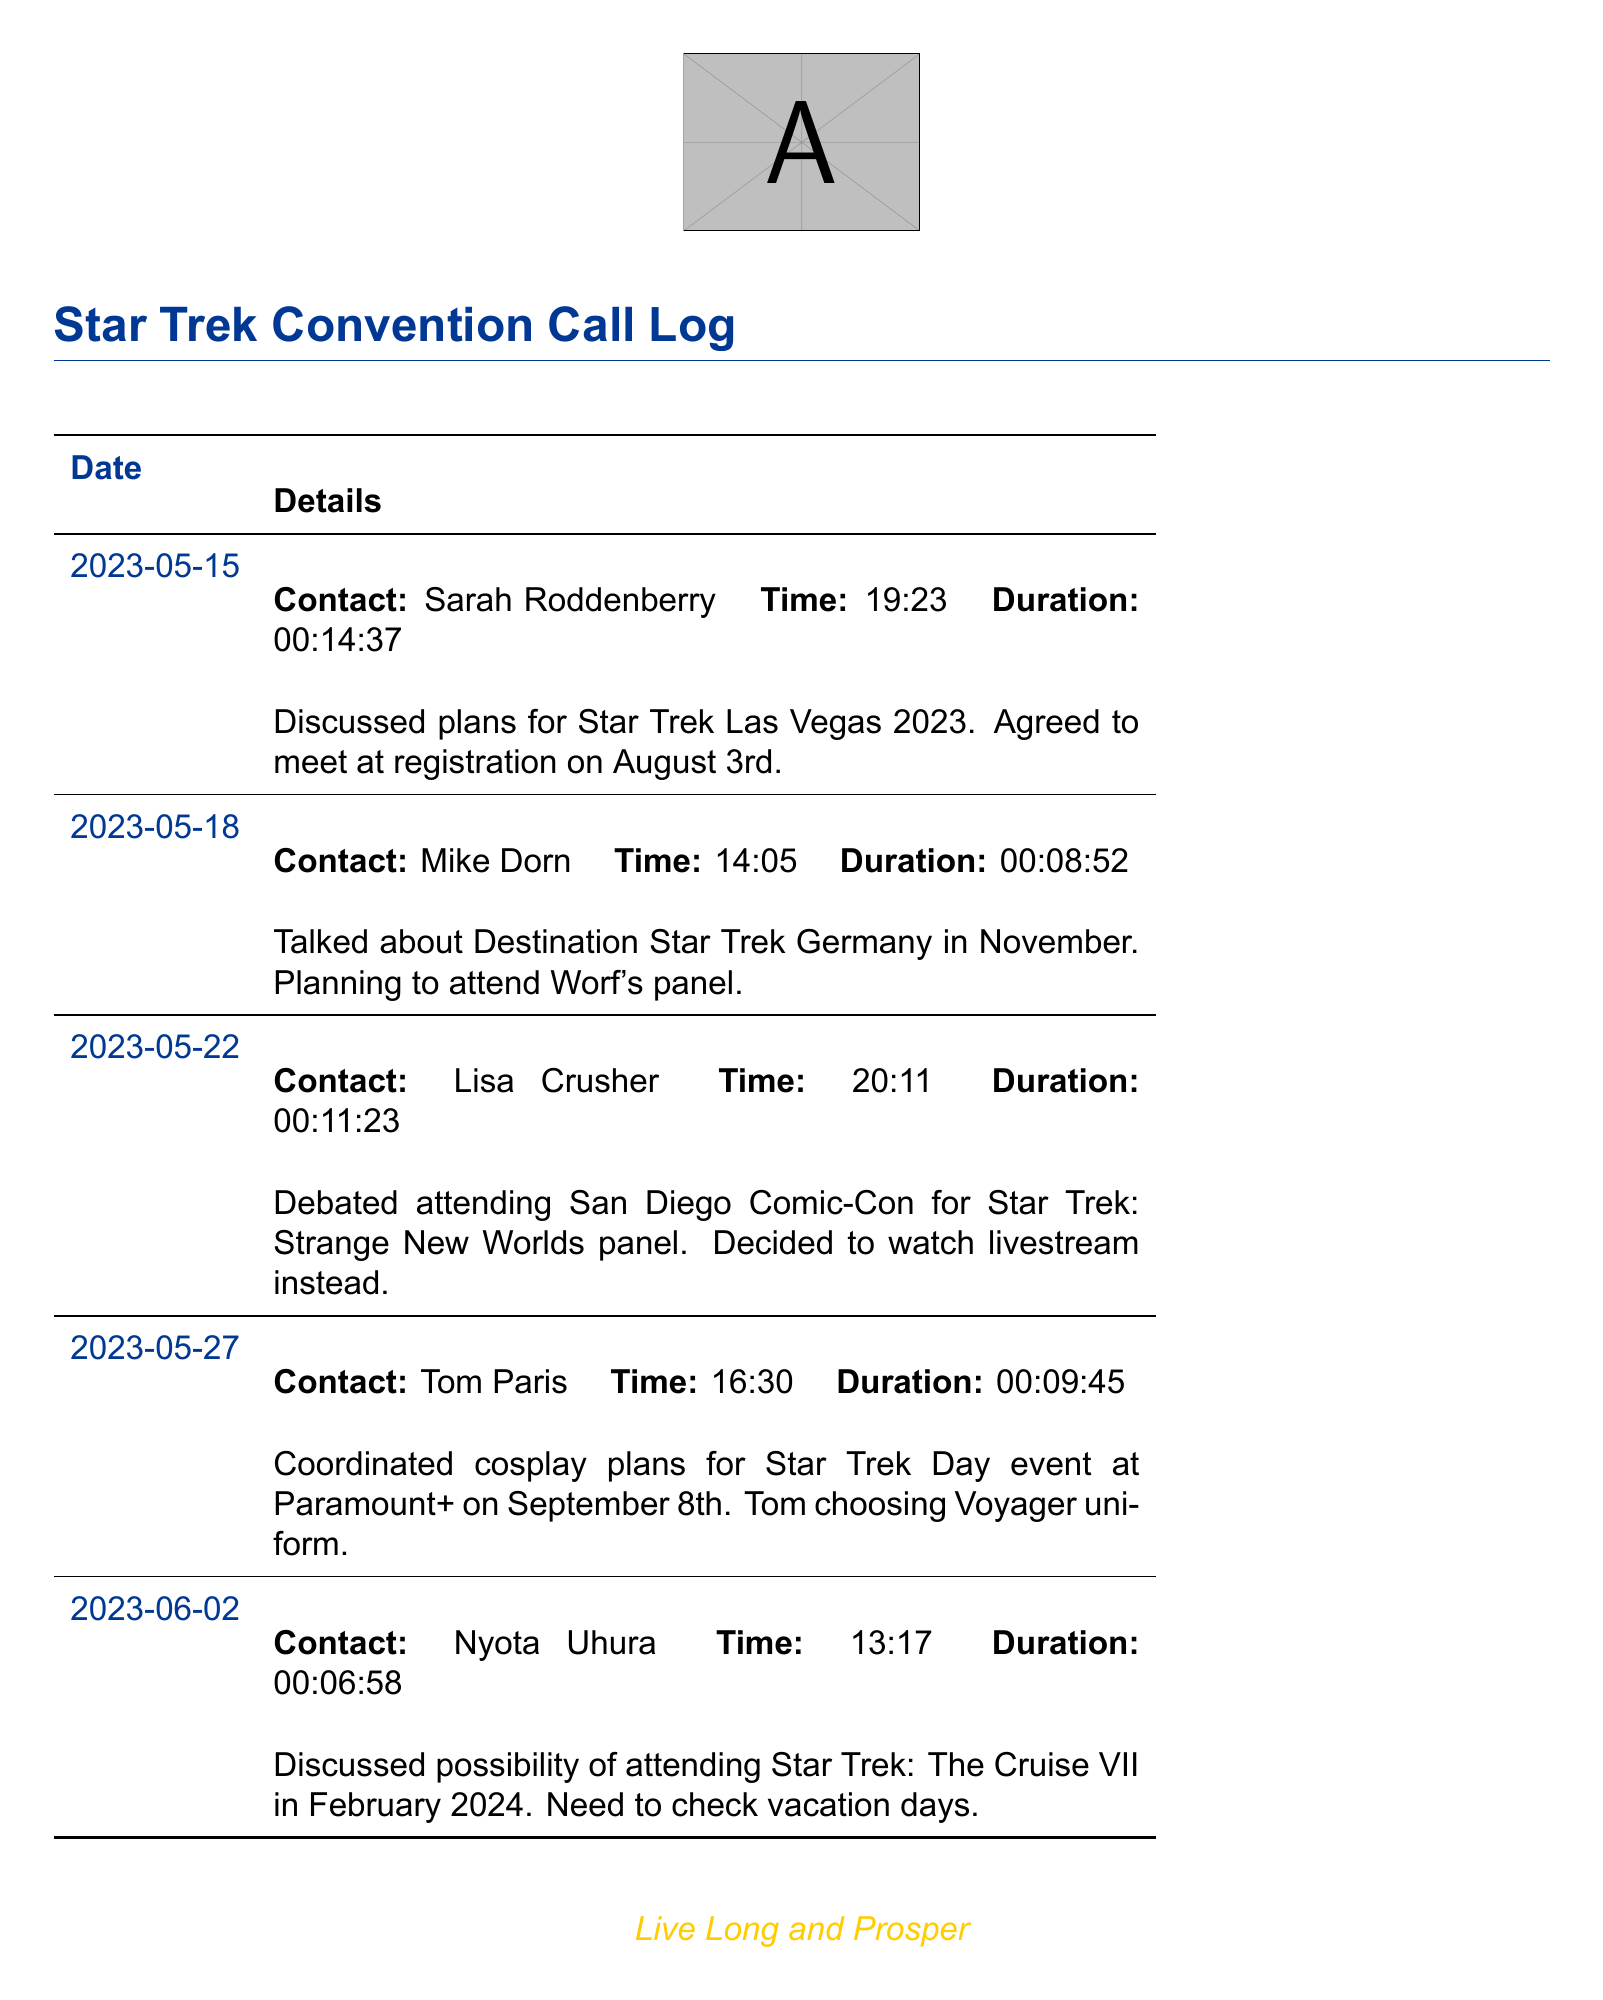what is the date of the call with Sarah Roddenberry? The date of the call with Sarah Roddenberry is clearly stated in the log.
Answer: 2023-05-15 how long did the conversation with Mike Dorn last? The duration of the conversation with Mike Dorn is listed in the details of the call.
Answer: 00:08:52 which convention was discussed in the call with Lisa Crusher? The call with Lisa Crusher mentioned a specific event related to Star Trek.
Answer: San Diego Comic-Con who is planning to wear a Voyager uniform? The details of the call with Tom Paris indicate his choice for the upcoming event.
Answer: Tom what date is Star Trek Day celebrated? The date for the Star Trek Day event was mentioned during the conversation with Tom Paris.
Answer: September 8th which event is planned for February 2024? The call with Nyota Uhura discusses a specific upcoming event for next year.
Answer: Star Trek: The Cruise VII how many contacts are listed in the call log? The total number of unique contacts can be inferred from the individual entries in the log.
Answer: 5 what panel is being planned for Destination Star Trek Germany? The conversation with Mike Dorn specifically mentions the type of panel at the convention.
Answer: Worf's panel 